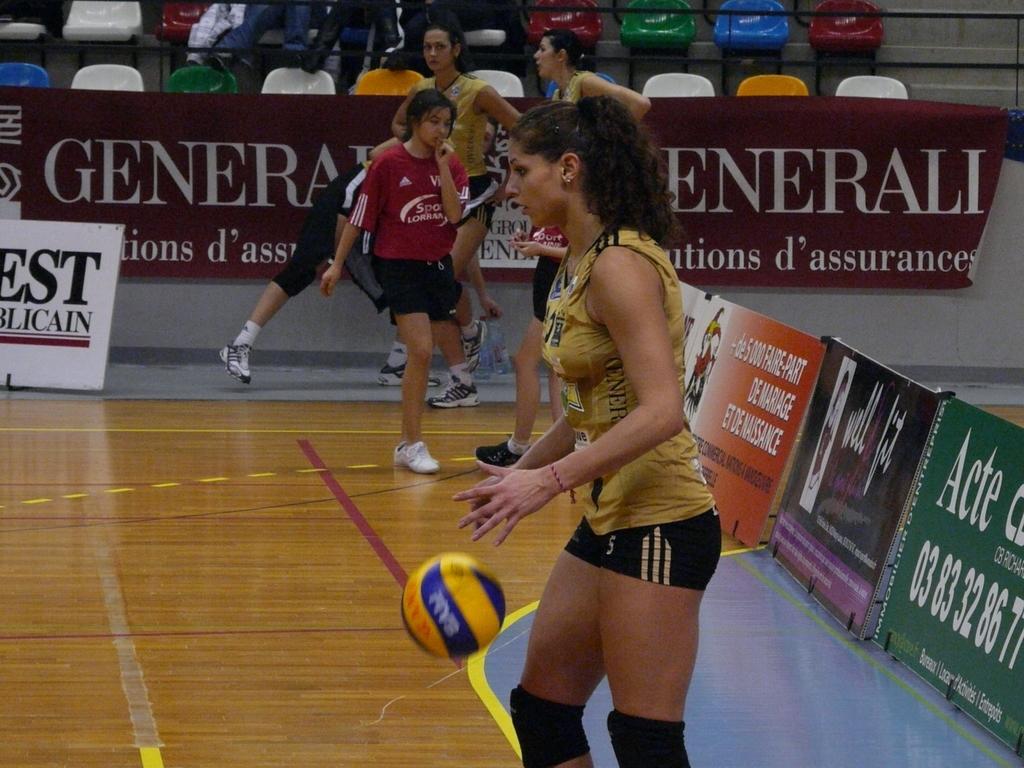Please provide a concise description of this image. In this picture there is a girl in the center of the image, she is about to catch the ball and there are other people in the background area of the image, there are posters in the image and there are chairs at the top side of the image. 